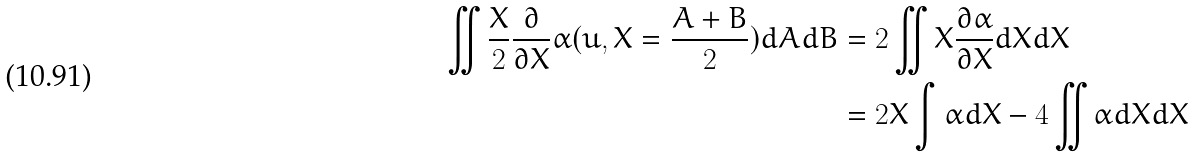Convert formula to latex. <formula><loc_0><loc_0><loc_500><loc_500>\iint \frac { X } { 2 } \frac { \partial } { \partial X } \alpha ( u , X = \frac { A + B } { 2 } ) d A d B & = 2 \iint X \frac { \partial \alpha } { \partial X } d X d X \\ & = 2 X \int \alpha d X - 4 \iint \alpha d X d X</formula> 